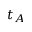<formula> <loc_0><loc_0><loc_500><loc_500>t _ { A }</formula> 